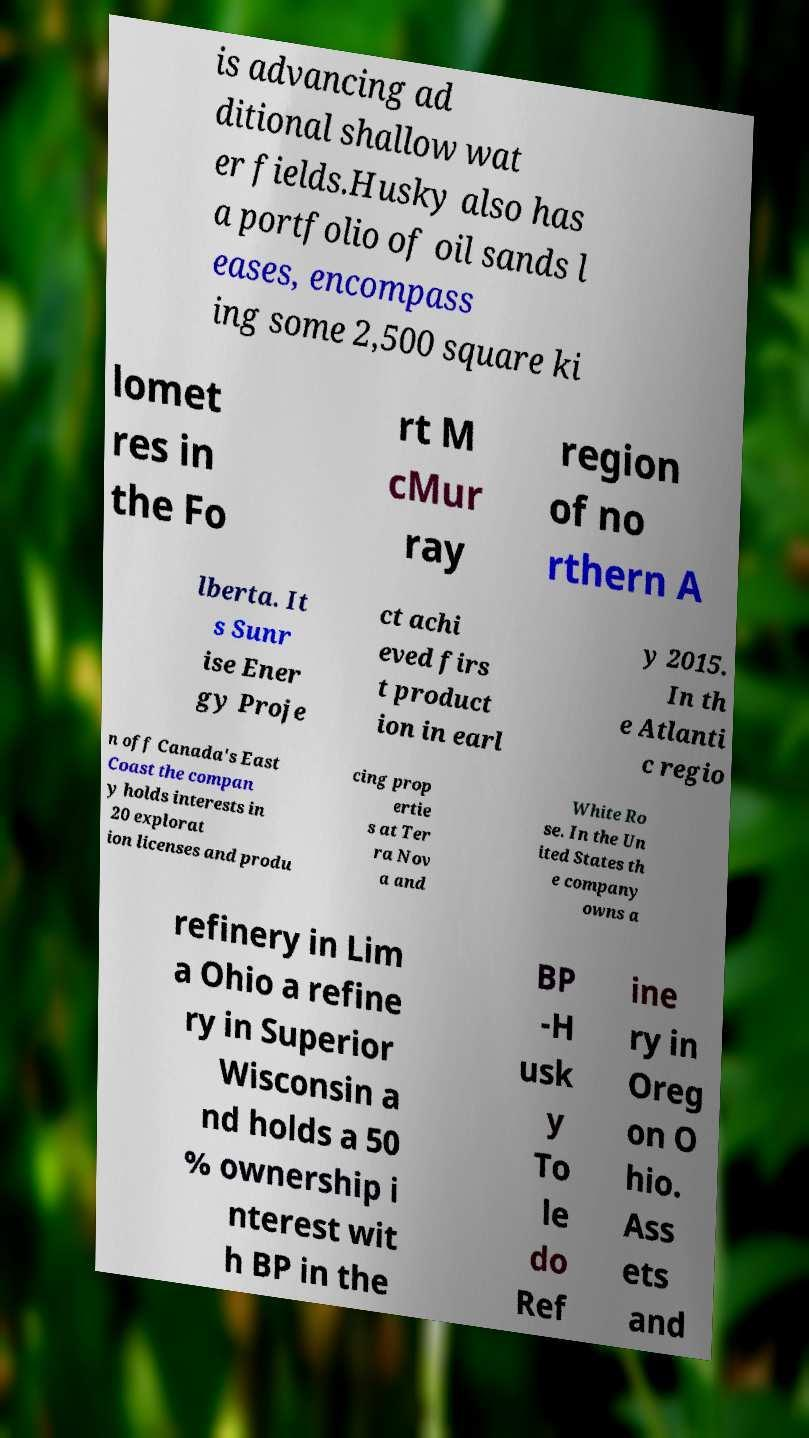Please read and relay the text visible in this image. What does it say? is advancing ad ditional shallow wat er fields.Husky also has a portfolio of oil sands l eases, encompass ing some 2,500 square ki lomet res in the Fo rt M cMur ray region of no rthern A lberta. It s Sunr ise Ener gy Proje ct achi eved firs t product ion in earl y 2015. In th e Atlanti c regio n off Canada's East Coast the compan y holds interests in 20 explorat ion licenses and produ cing prop ertie s at Ter ra Nov a and White Ro se. In the Un ited States th e company owns a refinery in Lim a Ohio a refine ry in Superior Wisconsin a nd holds a 50 % ownership i nterest wit h BP in the BP -H usk y To le do Ref ine ry in Oreg on O hio. Ass ets and 